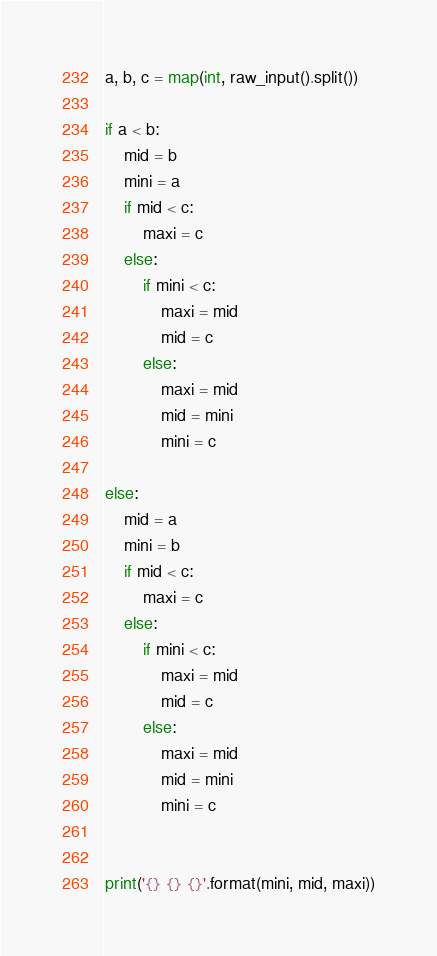<code> <loc_0><loc_0><loc_500><loc_500><_Python_>a, b, c = map(int, raw_input().split())

if a < b:
    mid = b
    mini = a
    if mid < c:
        maxi = c
    else:
        if mini < c:
            maxi = mid
            mid = c
        else:
            maxi = mid
            mid = mini
            mini = c

else:
    mid = a
    mini = b
    if mid < c:
        maxi = c
    else:
        if mini < c:
            maxi = mid
            mid = c
        else:
            maxi = mid
            mid = mini
            mini = c


print('{} {} {}'.format(mini, mid, maxi))</code> 